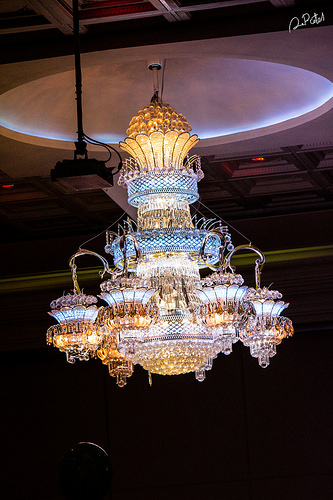<image>
Can you confirm if the ceiling light is on the ceiling? Yes. Looking at the image, I can see the ceiling light is positioned on top of the ceiling, with the ceiling providing support. 